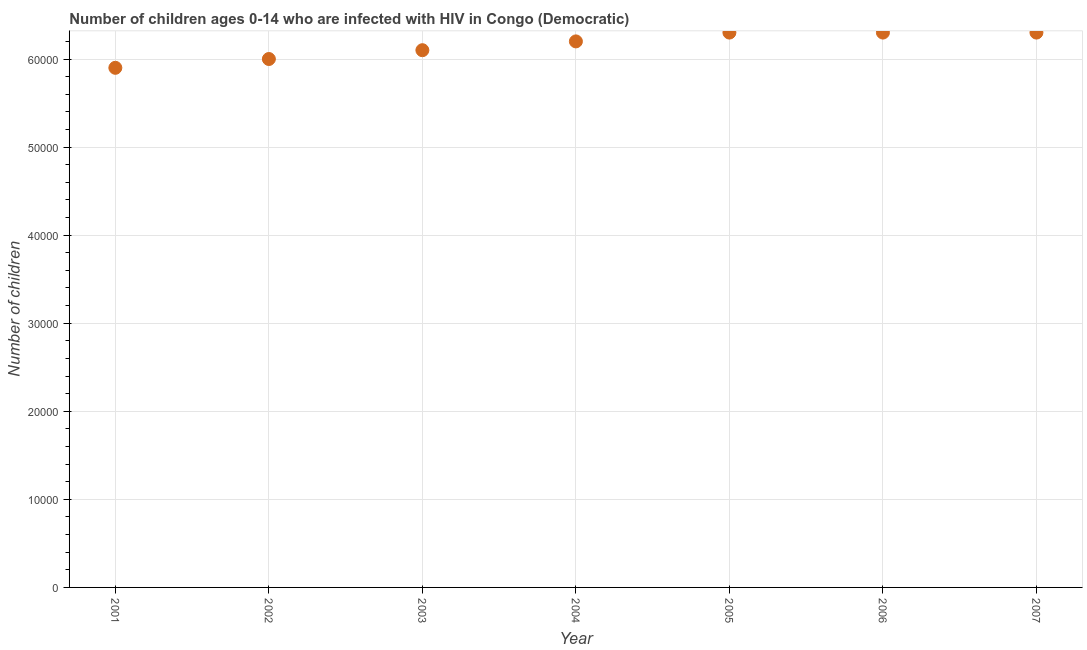What is the number of children living with hiv in 2002?
Make the answer very short. 6.00e+04. Across all years, what is the maximum number of children living with hiv?
Offer a very short reply. 6.30e+04. Across all years, what is the minimum number of children living with hiv?
Offer a very short reply. 5.90e+04. In which year was the number of children living with hiv minimum?
Provide a short and direct response. 2001. What is the sum of the number of children living with hiv?
Your answer should be very brief. 4.31e+05. What is the difference between the number of children living with hiv in 2003 and 2006?
Make the answer very short. -2000. What is the average number of children living with hiv per year?
Give a very brief answer. 6.16e+04. What is the median number of children living with hiv?
Give a very brief answer. 6.20e+04. In how many years, is the number of children living with hiv greater than 14000 ?
Offer a terse response. 7. Do a majority of the years between 2005 and 2006 (inclusive) have number of children living with hiv greater than 8000 ?
Your answer should be very brief. Yes. What is the ratio of the number of children living with hiv in 2004 to that in 2007?
Your response must be concise. 0.98. Is the number of children living with hiv in 2003 less than that in 2005?
Your answer should be compact. Yes. Is the difference between the number of children living with hiv in 2003 and 2006 greater than the difference between any two years?
Provide a succinct answer. No. What is the difference between the highest and the lowest number of children living with hiv?
Keep it short and to the point. 4000. What is the difference between two consecutive major ticks on the Y-axis?
Ensure brevity in your answer.  10000. Does the graph contain any zero values?
Your answer should be compact. No. What is the title of the graph?
Provide a succinct answer. Number of children ages 0-14 who are infected with HIV in Congo (Democratic). What is the label or title of the Y-axis?
Make the answer very short. Number of children. What is the Number of children in 2001?
Your response must be concise. 5.90e+04. What is the Number of children in 2003?
Ensure brevity in your answer.  6.10e+04. What is the Number of children in 2004?
Give a very brief answer. 6.20e+04. What is the Number of children in 2005?
Offer a very short reply. 6.30e+04. What is the Number of children in 2006?
Keep it short and to the point. 6.30e+04. What is the Number of children in 2007?
Your response must be concise. 6.30e+04. What is the difference between the Number of children in 2001 and 2002?
Give a very brief answer. -1000. What is the difference between the Number of children in 2001 and 2003?
Make the answer very short. -2000. What is the difference between the Number of children in 2001 and 2004?
Make the answer very short. -3000. What is the difference between the Number of children in 2001 and 2005?
Keep it short and to the point. -4000. What is the difference between the Number of children in 2001 and 2006?
Keep it short and to the point. -4000. What is the difference between the Number of children in 2001 and 2007?
Offer a terse response. -4000. What is the difference between the Number of children in 2002 and 2003?
Offer a very short reply. -1000. What is the difference between the Number of children in 2002 and 2004?
Your response must be concise. -2000. What is the difference between the Number of children in 2002 and 2005?
Provide a succinct answer. -3000. What is the difference between the Number of children in 2002 and 2006?
Offer a terse response. -3000. What is the difference between the Number of children in 2002 and 2007?
Offer a very short reply. -3000. What is the difference between the Number of children in 2003 and 2004?
Give a very brief answer. -1000. What is the difference between the Number of children in 2003 and 2005?
Keep it short and to the point. -2000. What is the difference between the Number of children in 2003 and 2006?
Your answer should be very brief. -2000. What is the difference between the Number of children in 2003 and 2007?
Offer a terse response. -2000. What is the difference between the Number of children in 2004 and 2005?
Provide a short and direct response. -1000. What is the difference between the Number of children in 2004 and 2006?
Ensure brevity in your answer.  -1000. What is the difference between the Number of children in 2004 and 2007?
Your answer should be very brief. -1000. What is the difference between the Number of children in 2006 and 2007?
Ensure brevity in your answer.  0. What is the ratio of the Number of children in 2001 to that in 2002?
Provide a short and direct response. 0.98. What is the ratio of the Number of children in 2001 to that in 2005?
Make the answer very short. 0.94. What is the ratio of the Number of children in 2001 to that in 2006?
Your answer should be very brief. 0.94. What is the ratio of the Number of children in 2001 to that in 2007?
Your answer should be very brief. 0.94. What is the ratio of the Number of children in 2002 to that in 2003?
Your answer should be compact. 0.98. What is the ratio of the Number of children in 2002 to that in 2006?
Provide a short and direct response. 0.95. What is the ratio of the Number of children in 2002 to that in 2007?
Keep it short and to the point. 0.95. What is the ratio of the Number of children in 2003 to that in 2007?
Ensure brevity in your answer.  0.97. What is the ratio of the Number of children in 2005 to that in 2007?
Give a very brief answer. 1. 